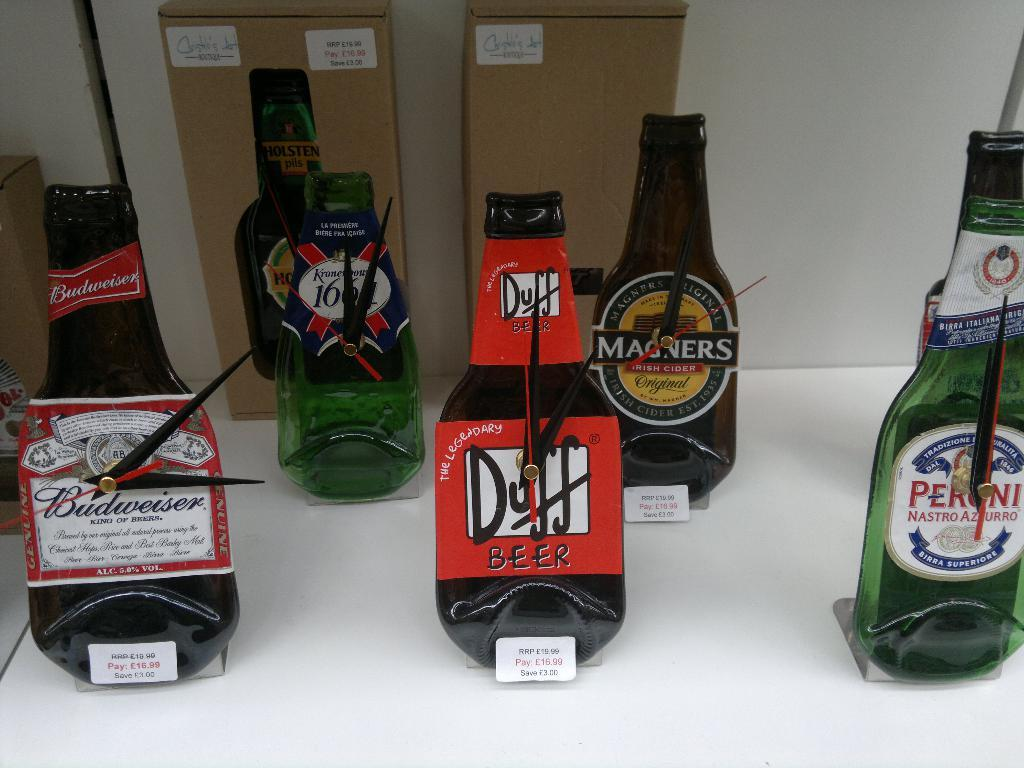<image>
Provide a brief description of the given image. Flat beer bottles with the Duff Beer being in the middle. 